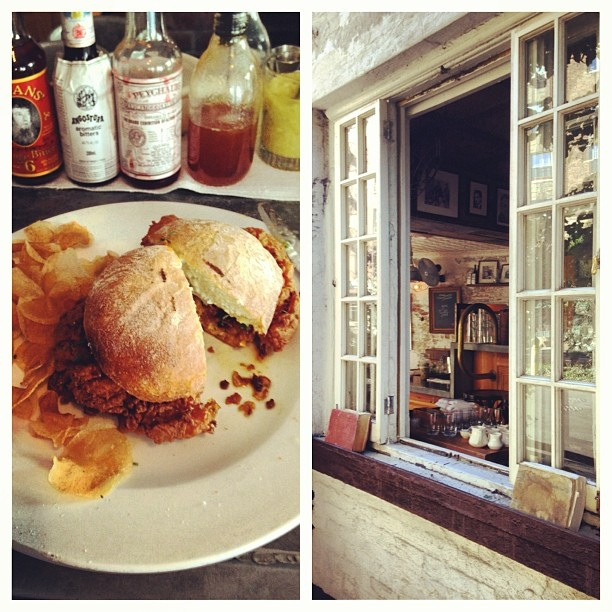Extract all visible text content from this image. ANS 6 